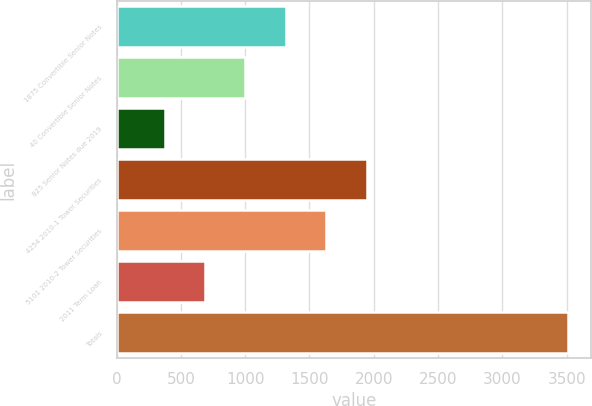Convert chart. <chart><loc_0><loc_0><loc_500><loc_500><bar_chart><fcel>1875 Convertible Senior Notes<fcel>40 Convertible Senior Notes<fcel>825 Senior Notes due 2019<fcel>4254 2010-1 Tower Securities<fcel>5101 2010-2 Tower Securities<fcel>2011 Term Loan<fcel>Totals<nl><fcel>1316.25<fcel>1002.5<fcel>375<fcel>1943.75<fcel>1630<fcel>688.75<fcel>3512.5<nl></chart> 